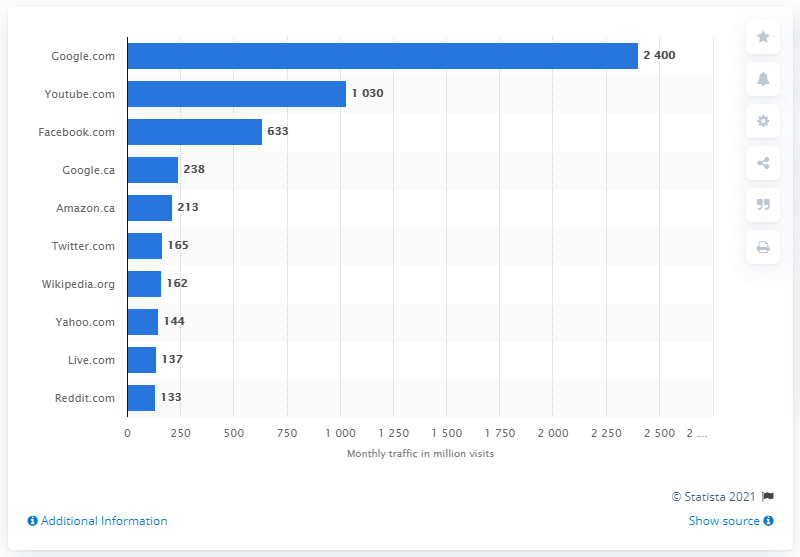Give some essential details in this illustration. As of December 2020, Google.com was the top-ranking website in Canada. According to data, YouTube was ranked as the second most visited website in Canada in terms of monthly traffic. 